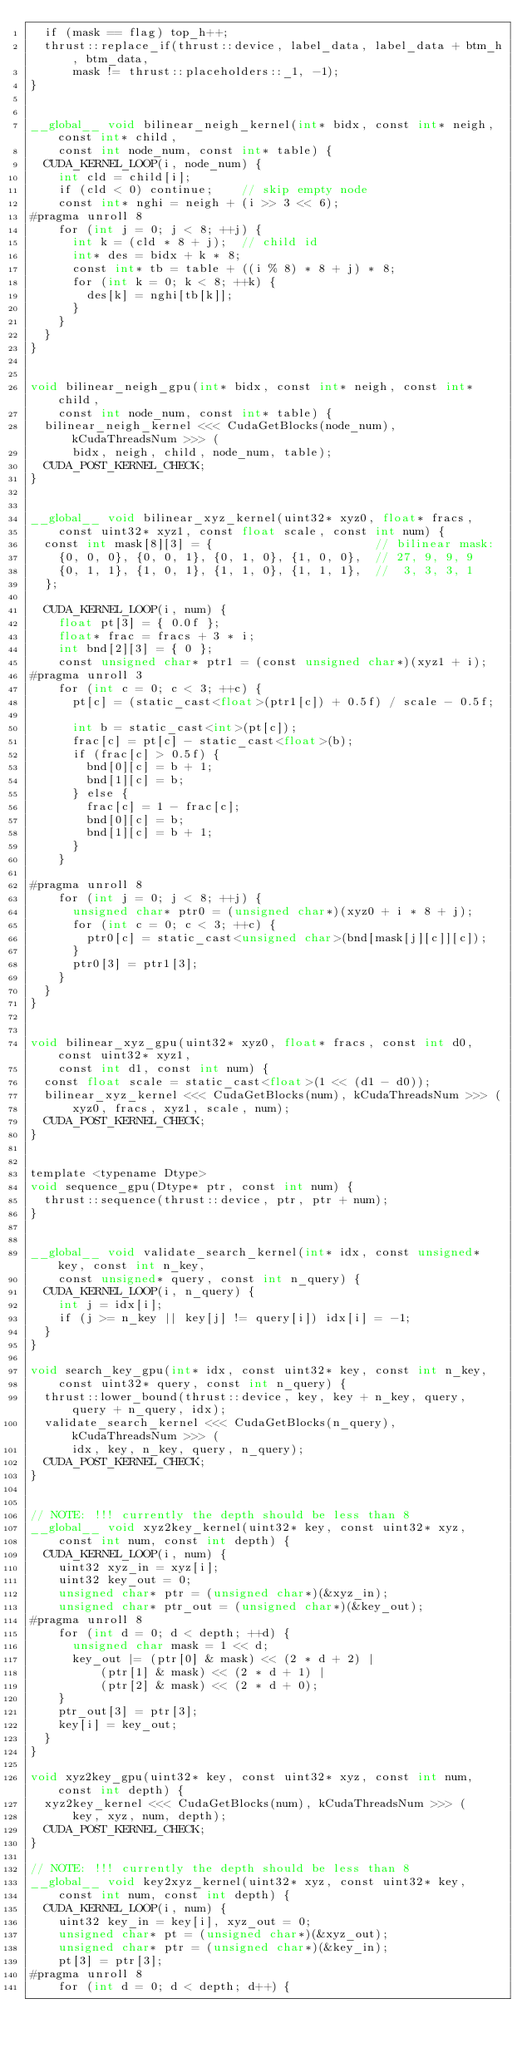Convert code to text. <code><loc_0><loc_0><loc_500><loc_500><_Cuda_>  if (mask == flag) top_h++;
  thrust::replace_if(thrust::device, label_data, label_data + btm_h, btm_data,
      mask != thrust::placeholders::_1, -1);
}


__global__ void bilinear_neigh_kernel(int* bidx, const int* neigh, const int* child,
    const int node_num, const int* table) {
  CUDA_KERNEL_LOOP(i, node_num) {
    int cld = child[i];
    if (cld < 0) continue;    // skip empty node
    const int* nghi = neigh + (i >> 3 << 6);
#pragma unroll 8
    for (int j = 0; j < 8; ++j) {
      int k = (cld * 8 + j);  // child id
      int* des = bidx + k * 8;
      const int* tb = table + ((i % 8) * 8 + j) * 8;
      for (int k = 0; k < 8; ++k) {
        des[k] = nghi[tb[k]];
      }
    }
  }
}


void bilinear_neigh_gpu(int* bidx, const int* neigh, const int* child,
    const int node_num, const int* table) {
  bilinear_neigh_kernel <<< CudaGetBlocks(node_num), kCudaThreadsNum >>> (
      bidx, neigh, child, node_num, table);
  CUDA_POST_KERNEL_CHECK;
}


__global__ void bilinear_xyz_kernel(uint32* xyz0, float* fracs,
    const uint32* xyz1, const float scale, const int num) {
  const int mask[8][3] = {                       // bilinear mask:
    {0, 0, 0}, {0, 0, 1}, {0, 1, 0}, {1, 0, 0},  // 27, 9, 9, 9
    {0, 1, 1}, {1, 0, 1}, {1, 1, 0}, {1, 1, 1},  //  3, 3, 3, 1
  };

  CUDA_KERNEL_LOOP(i, num) {
    float pt[3] = { 0.0f };
    float* frac = fracs + 3 * i;
    int bnd[2][3] = { 0 };
    const unsigned char* ptr1 = (const unsigned char*)(xyz1 + i);
#pragma unroll 3
    for (int c = 0; c < 3; ++c) {
      pt[c] = (static_cast<float>(ptr1[c]) + 0.5f) / scale - 0.5f;

      int b = static_cast<int>(pt[c]);
      frac[c] = pt[c] - static_cast<float>(b);
      if (frac[c] > 0.5f) {
        bnd[0][c] = b + 1;
        bnd[1][c] = b;
      } else {
        frac[c] = 1 - frac[c];
        bnd[0][c] = b;
        bnd[1][c] = b + 1;
      }
    }

#pragma unroll 8
    for (int j = 0; j < 8; ++j) {
      unsigned char* ptr0 = (unsigned char*)(xyz0 + i * 8 + j);
      for (int c = 0; c < 3; ++c) {
        ptr0[c] = static_cast<unsigned char>(bnd[mask[j][c]][c]);
      }
      ptr0[3] = ptr1[3];
    }
  }
}


void bilinear_xyz_gpu(uint32* xyz0, float* fracs, const int d0, const uint32* xyz1,
    const int d1, const int num) {
  const float scale = static_cast<float>(1 << (d1 - d0));
  bilinear_xyz_kernel <<< CudaGetBlocks(num), kCudaThreadsNum >>> (
      xyz0, fracs, xyz1, scale, num);
  CUDA_POST_KERNEL_CHECK;
}


template <typename Dtype>
void sequence_gpu(Dtype* ptr, const int num) {
  thrust::sequence(thrust::device, ptr, ptr + num);
}


__global__ void validate_search_kernel(int* idx, const unsigned* key, const int n_key,
    const unsigned* query, const int n_query) {
  CUDA_KERNEL_LOOP(i, n_query) {
    int j = idx[i];
    if (j >= n_key || key[j] != query[i]) idx[i] = -1;
  }
}

void search_key_gpu(int* idx, const uint32* key, const int n_key,
    const uint32* query, const int n_query) {
  thrust::lower_bound(thrust::device, key, key + n_key, query, query + n_query, idx);
  validate_search_kernel <<< CudaGetBlocks(n_query), kCudaThreadsNum >>> (
      idx, key, n_key, query, n_query);
  CUDA_POST_KERNEL_CHECK;
}


// NOTE: !!! currently the depth should be less than 8
__global__ void xyz2key_kernel(uint32* key, const uint32* xyz,
    const int num, const int depth) {
  CUDA_KERNEL_LOOP(i, num) {
    uint32 xyz_in = xyz[i];
    uint32 key_out = 0;
    unsigned char* ptr = (unsigned char*)(&xyz_in);
    unsigned char* ptr_out = (unsigned char*)(&key_out);
#pragma unroll 8
    for (int d = 0; d < depth; ++d) {
      unsigned char mask = 1 << d;
      key_out |= (ptr[0] & mask) << (2 * d + 2) |
          (ptr[1] & mask) << (2 * d + 1) |
          (ptr[2] & mask) << (2 * d + 0);
    }
    ptr_out[3] = ptr[3];
    key[i] = key_out;
  }
}

void xyz2key_gpu(uint32* key, const uint32* xyz, const int num, const int depth) {
  xyz2key_kernel <<< CudaGetBlocks(num), kCudaThreadsNum >>> (
      key, xyz, num, depth);
  CUDA_POST_KERNEL_CHECK;
}

// NOTE: !!! currently the depth should be less than 8
__global__ void key2xyz_kernel(uint32* xyz, const uint32* key,
    const int num, const int depth) {
  CUDA_KERNEL_LOOP(i, num) {
    uint32 key_in = key[i], xyz_out = 0;
    unsigned char* pt = (unsigned char*)(&xyz_out);
    unsigned char* ptr = (unsigned char*)(&key_in);
    pt[3] = ptr[3];
#pragma unroll 8
    for (int d = 0; d < depth; d++) {</code> 